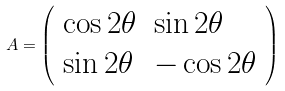<formula> <loc_0><loc_0><loc_500><loc_500>A = { \left ( \begin{array} { l l } { \cos { 2 \theta } } & { \sin { 2 \theta } } \\ { \sin { 2 \theta } } & { - \cos { 2 \theta } } \end{array} \right ) }</formula> 